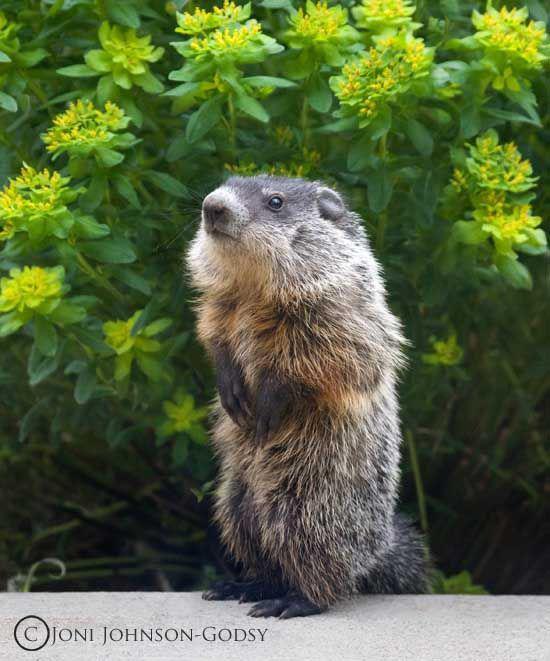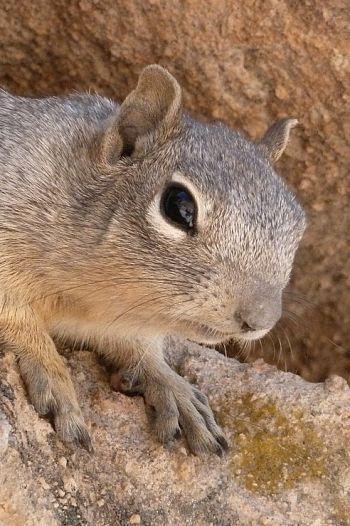The first image is the image on the left, the second image is the image on the right. Examine the images to the left and right. Is the description "The left image includes a right-facing marmot with its front paws propped up on something." accurate? Answer yes or no. No. The first image is the image on the left, the second image is the image on the right. Assess this claim about the two images: "There is one image that does not include green vegetation in the background.". Correct or not? Answer yes or no. Yes. 